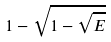Convert formula to latex. <formula><loc_0><loc_0><loc_500><loc_500>1 - \sqrt { 1 - \sqrt { E } }</formula> 